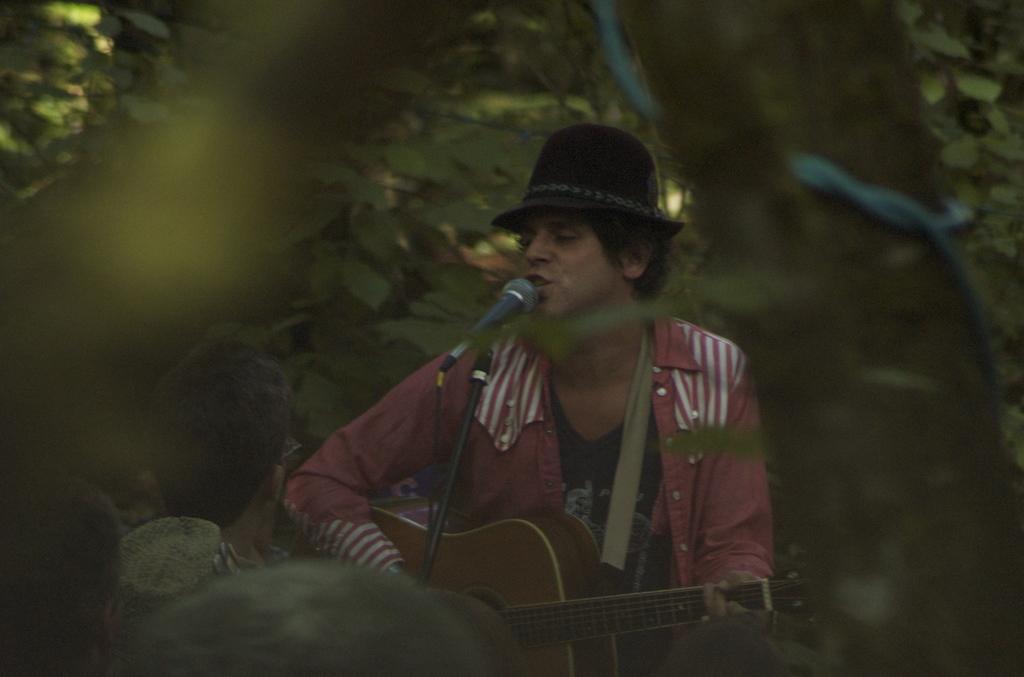In one or two sentences, can you explain what this image depicts? In the image there is a man holding a guitar and playing in front of a microphone and opened his mouth for singing, in background we can see trees. 